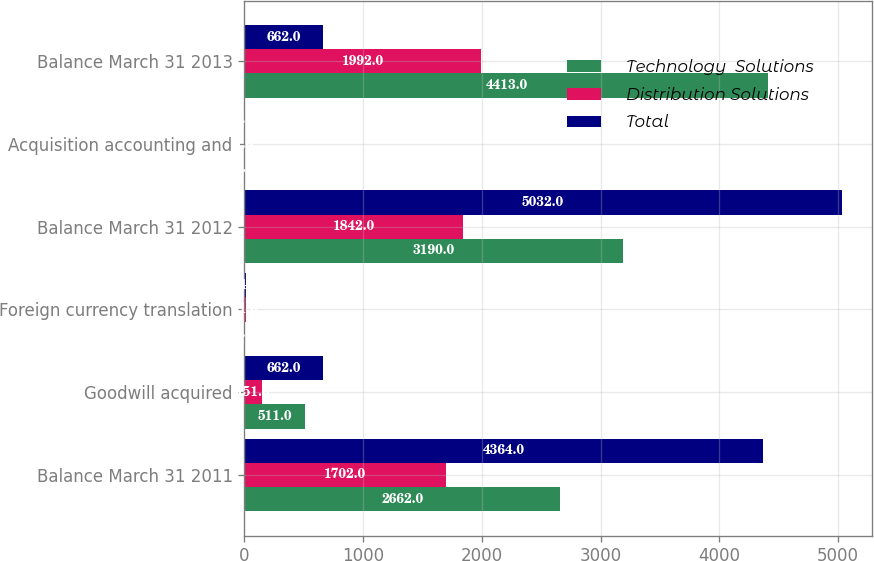<chart> <loc_0><loc_0><loc_500><loc_500><stacked_bar_chart><ecel><fcel>Balance March 31 2011<fcel>Goodwill acquired<fcel>Foreign currency translation<fcel>Balance March 31 2012<fcel>Acquisition accounting and<fcel>Balance March 31 2013<nl><fcel>Technology  Solutions<fcel>2662<fcel>511<fcel>3<fcel>3190<fcel>6<fcel>4413<nl><fcel>Distribution Solutions<fcel>1702<fcel>151<fcel>11<fcel>1842<fcel>1<fcel>1992<nl><fcel>Total<fcel>4364<fcel>662<fcel>14<fcel>5032<fcel>5<fcel>662<nl></chart> 